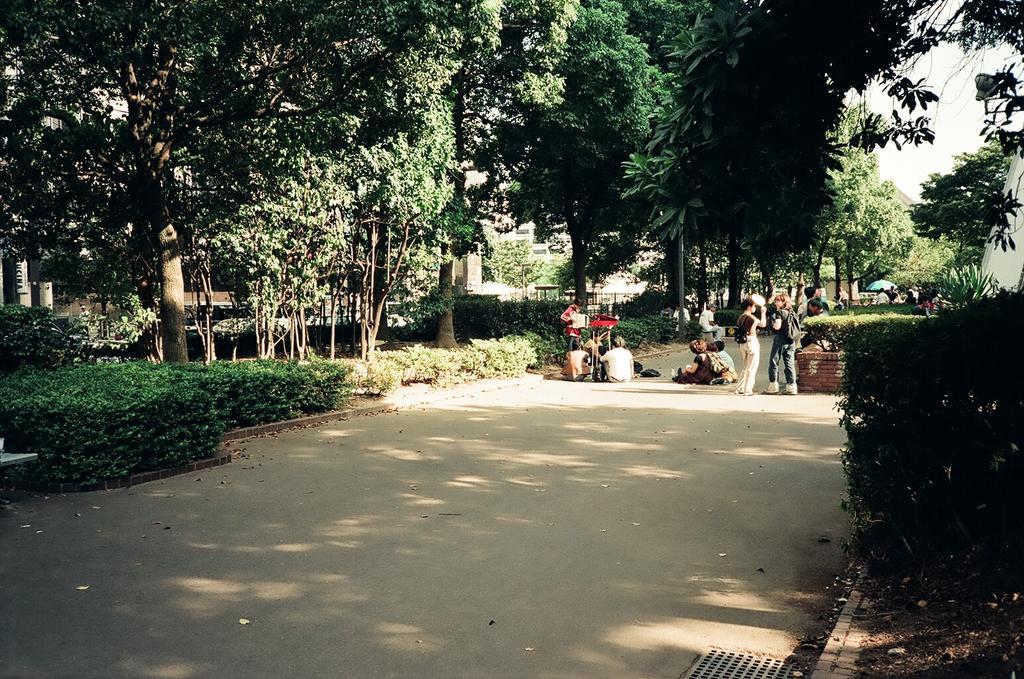Please provide a concise description of this image. In this image we can see a group of trees and plants. In front of the plants we can see persons. Behind the trees we can see the buildings. In the top right, we can see the sky. 